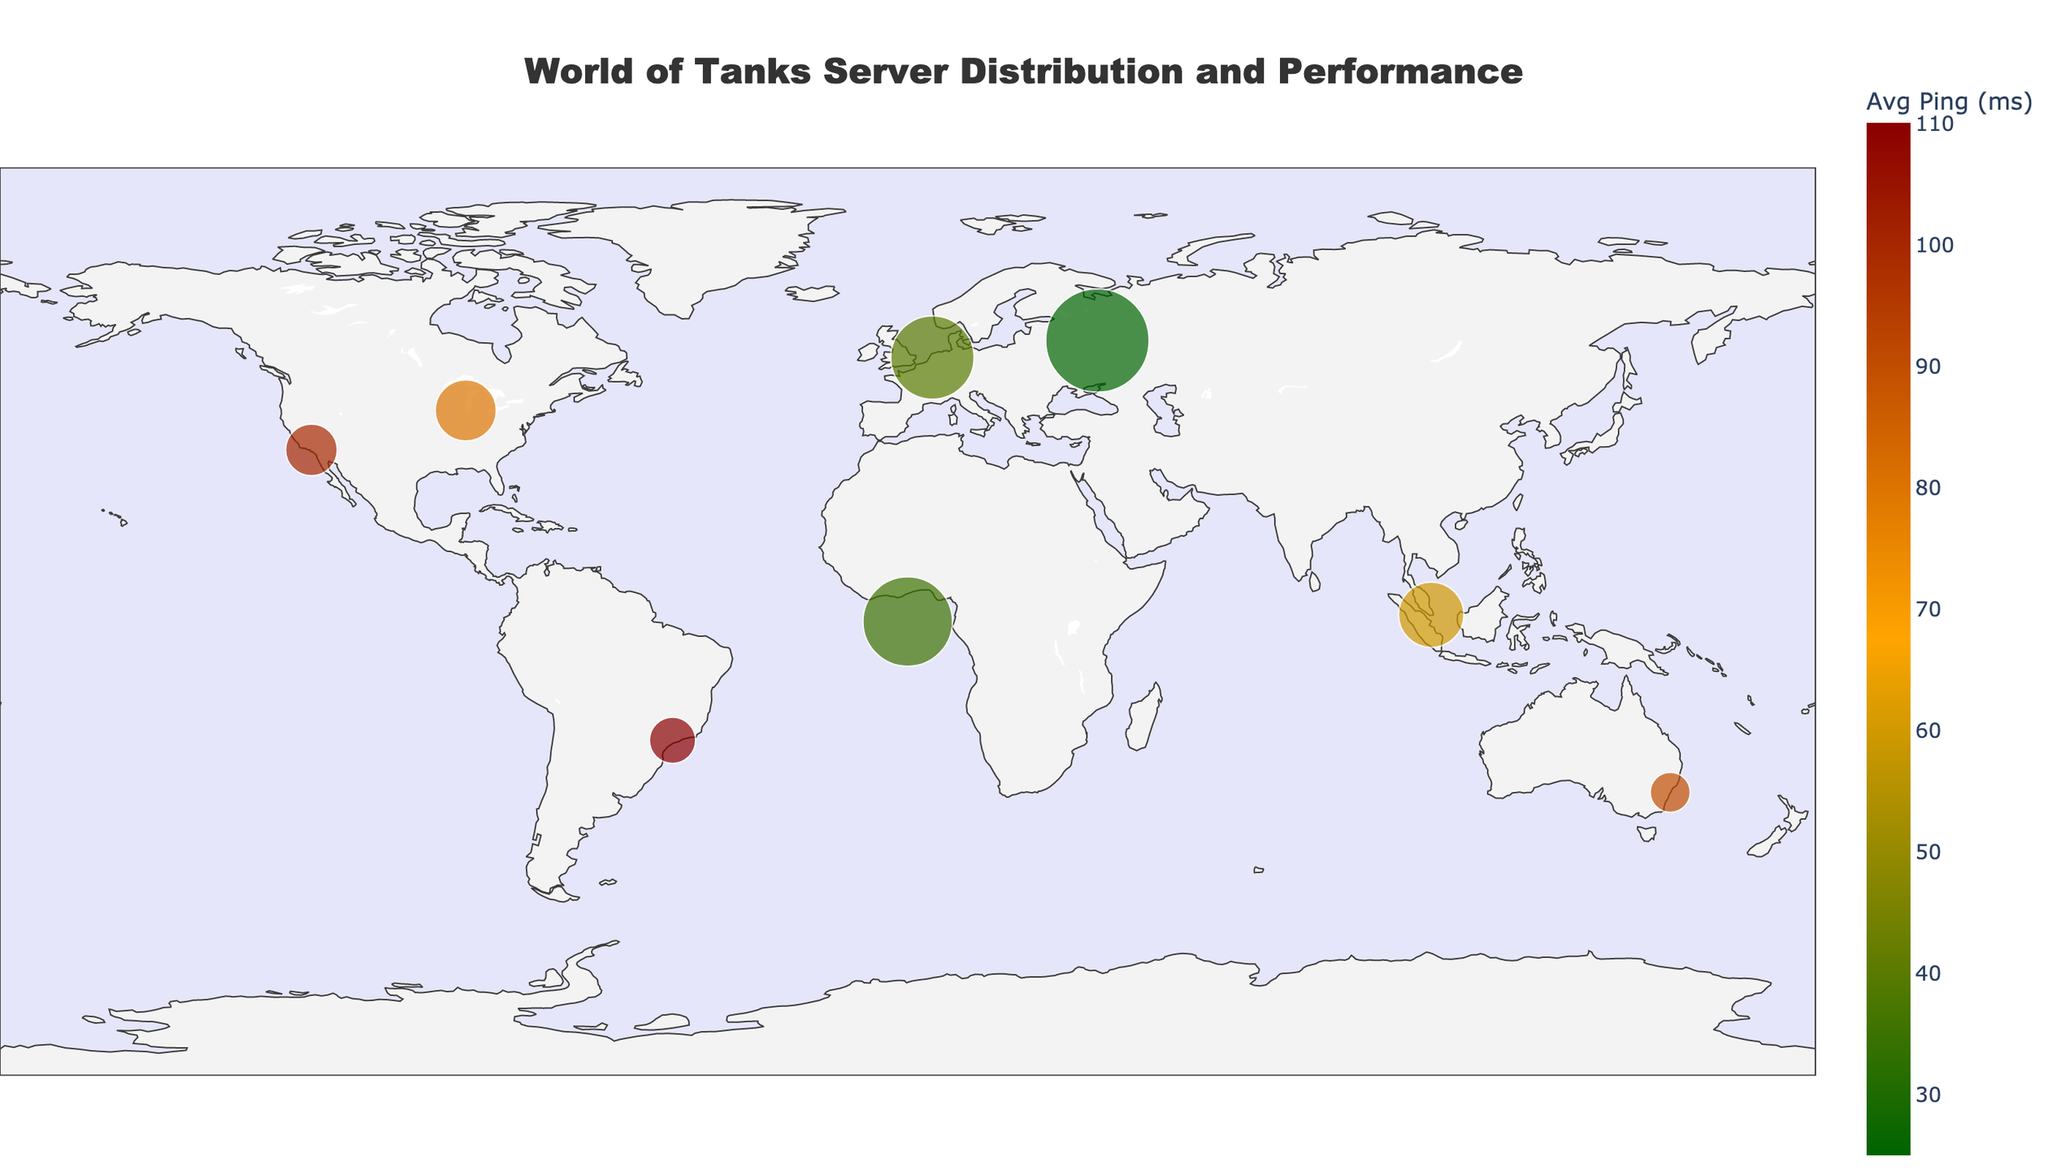What is the title of the figure? The title is usually displayed prominently at the top of the figure. It describes the overall topic or subject matter of the visualization.
Answer: World of Tanks Server Distribution and Performance Which server has the highest average ping time? Look for the point with the highest color value on the color scale (dark red) and check the hover information or legend for average ping times.
Answer: SA (São Paulo) What are the average ping times for EU1 and EU2 servers? Locate the data points for EU1 and EU2 on the figure and refer to the hover information to extract their average ping times.
Answer: 35 ms for EU1 and 40 ms for EU2 How many servers are displayed on the plot? Count the number of points (markers) on the geographic plot representing different servers.
Answer: 8 Which server has the most active players? Identify the largest marker on the plot (size represents active players), and check the hover information or legend.
Answer: RU (Moscow) Which server has the lowest average ping time, and what is it? Locate the point with the lowest color value on the color scale (dark green) and check the hover information for the average ping times.
Answer: RU (Moscow), 25 ms Which server is located in Frankfurt, and what are its average ping time and active players? Locate the data point associated with Frankfurt and refer to the hover information to extract the server name, average ping time, and active players.
Answer: EU1, 35 ms, 150,000 